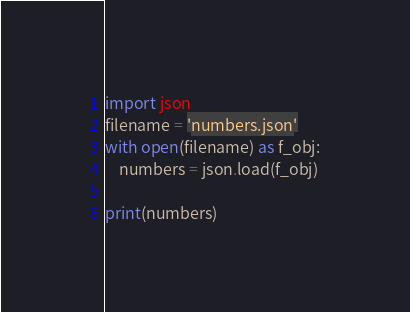Convert code to text. <code><loc_0><loc_0><loc_500><loc_500><_Python_>import json
filename = 'numbers.json'
with open(filename) as f_obj:
    numbers = json.load(f_obj)

print(numbers)
</code> 